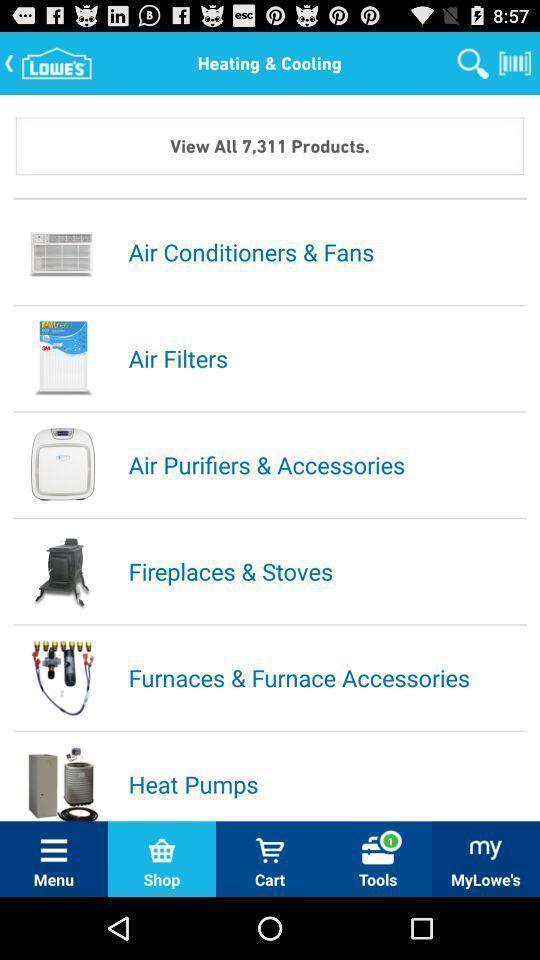Describe the key features of this screenshot. List of products in shopping app. 